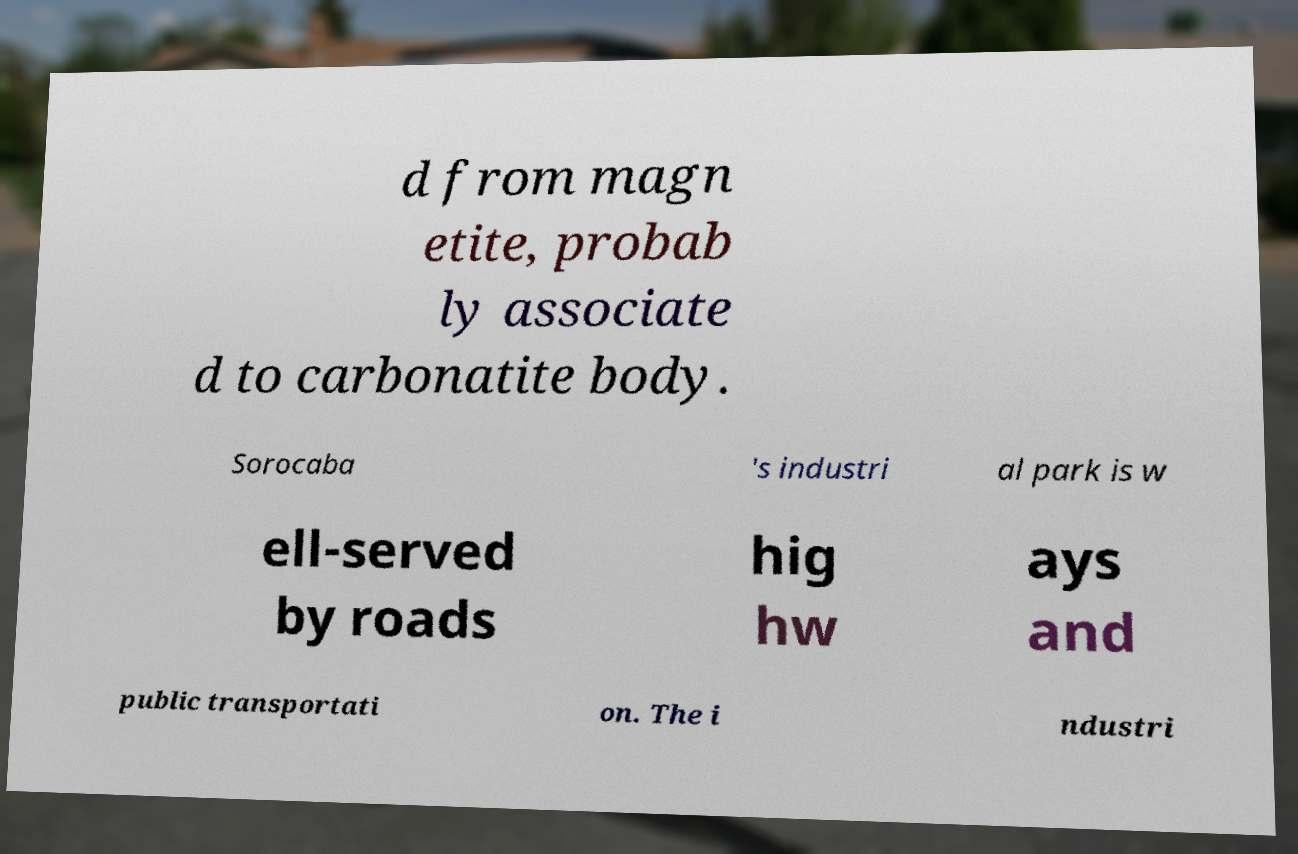Can you read and provide the text displayed in the image?This photo seems to have some interesting text. Can you extract and type it out for me? d from magn etite, probab ly associate d to carbonatite body. Sorocaba 's industri al park is w ell-served by roads hig hw ays and public transportati on. The i ndustri 